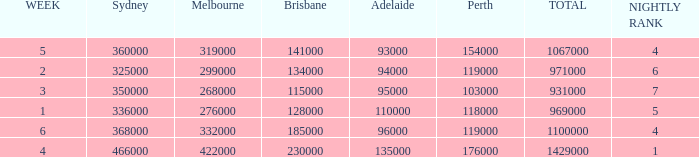What was the rating for Brisbane the week that Adelaide had 94000? 134000.0. 